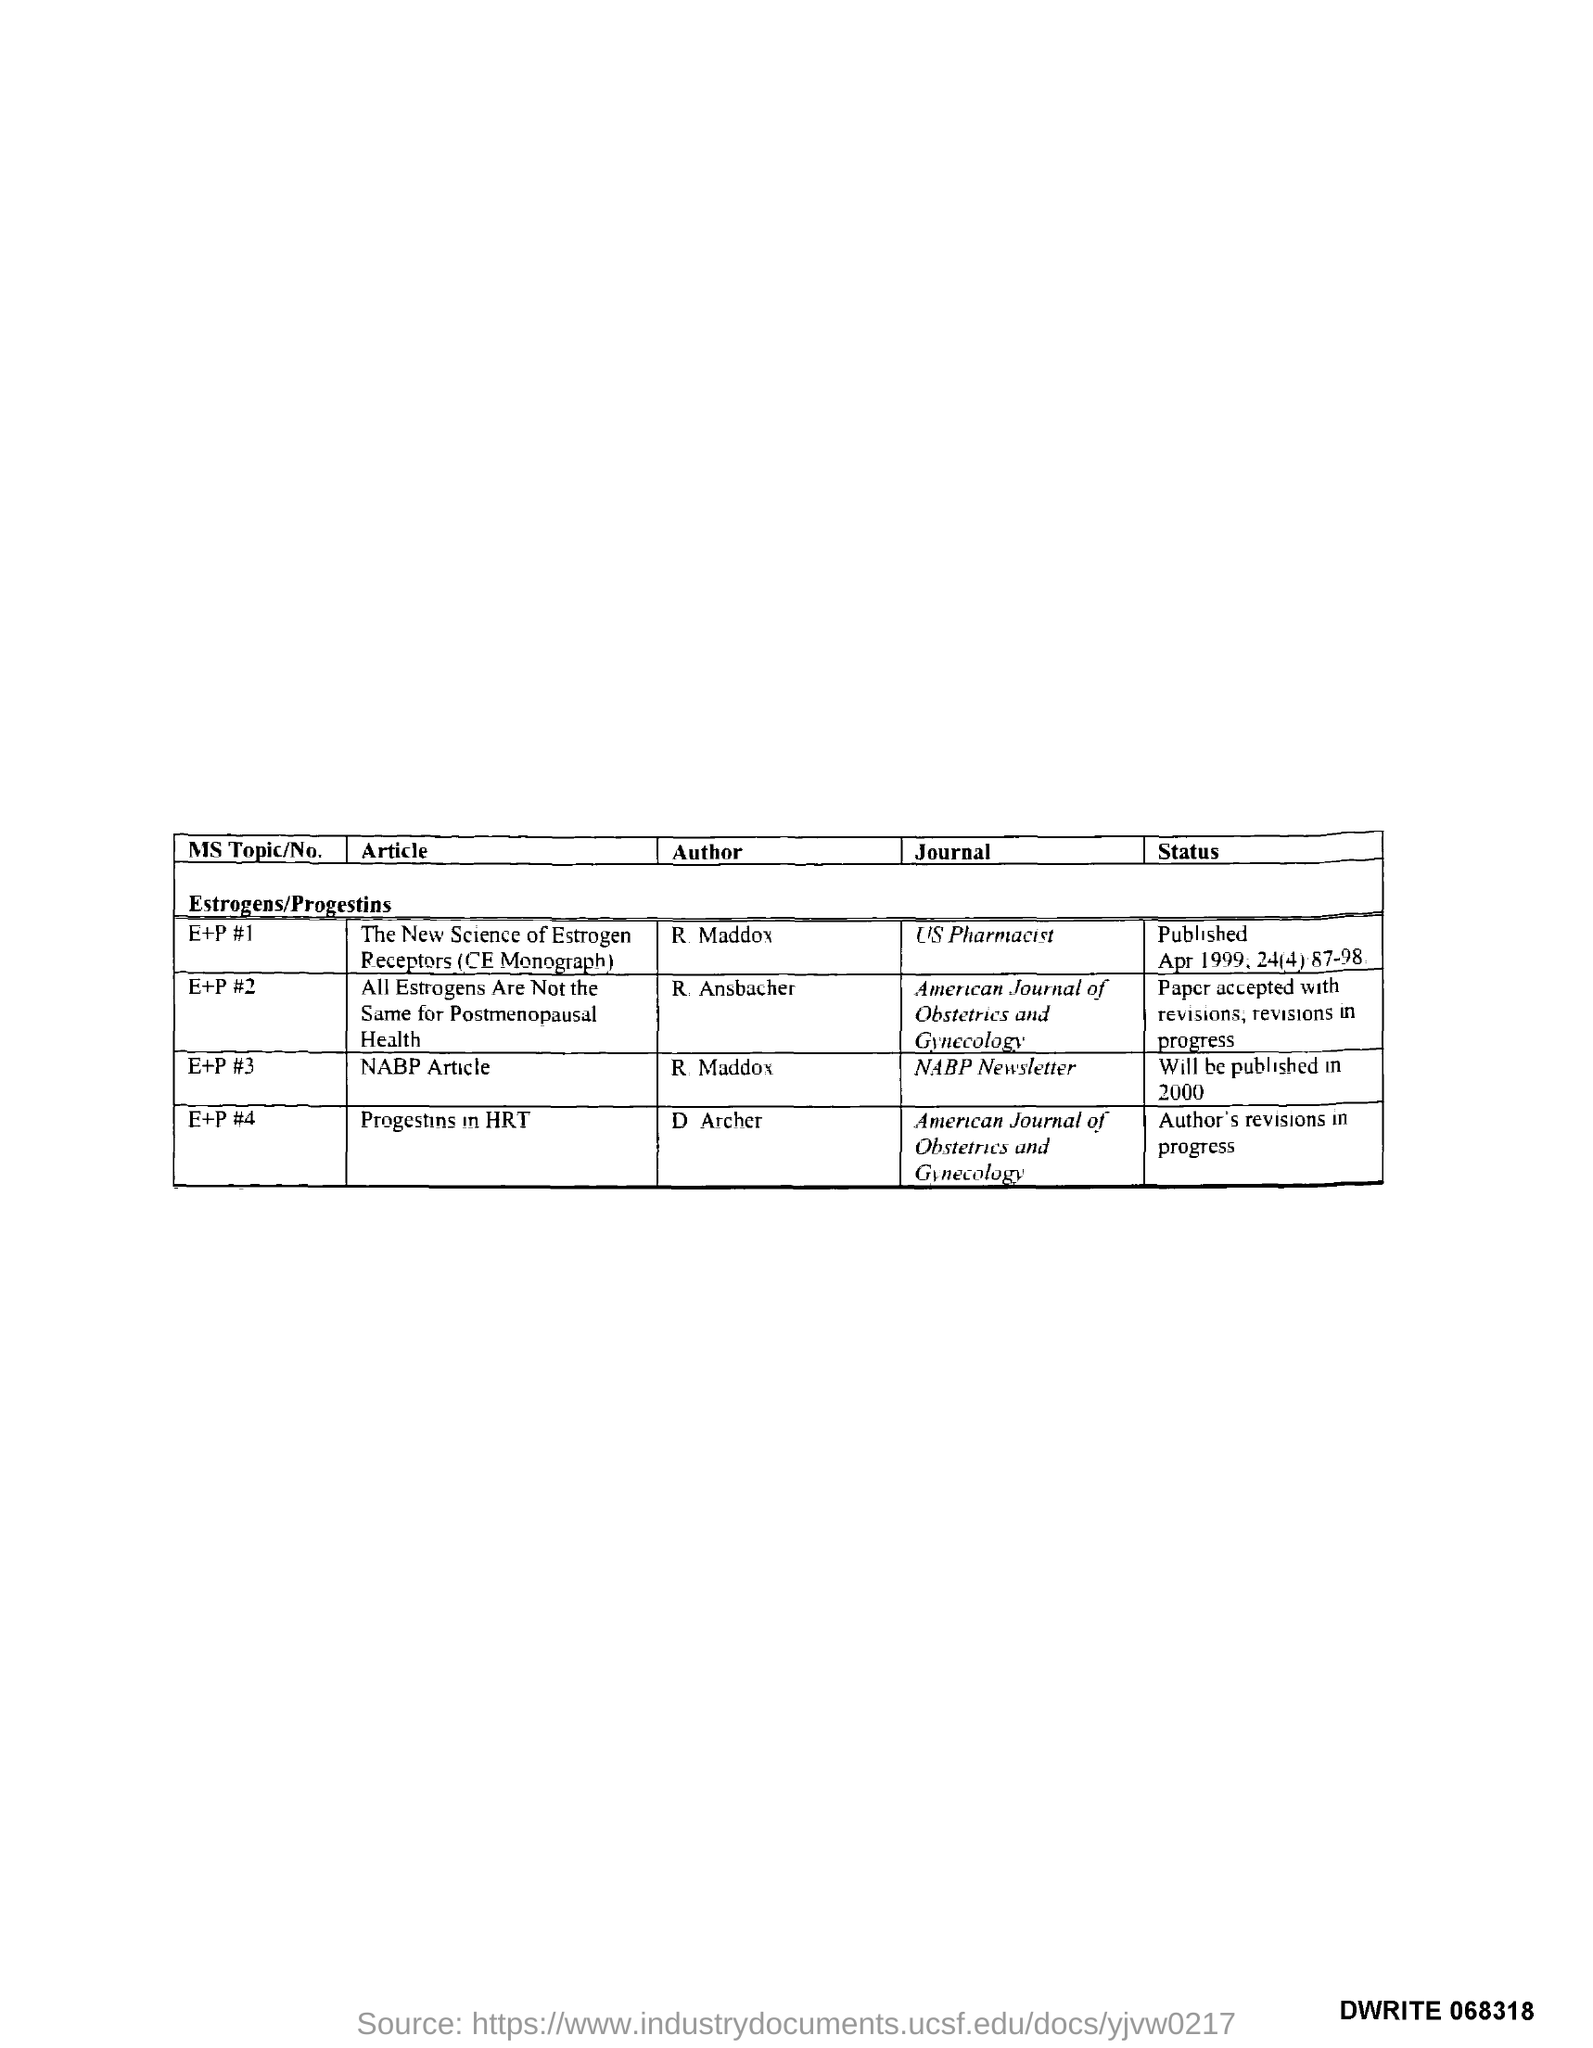Who is the author of the article titled "The New Science of Estrogen Receptors (CE Monograph)"?
Your response must be concise. R Maddox. In which journal , the article titled "The New Science of Estrogen Receptors (CE Monograph)" is published?
Provide a short and direct response. US Pharmacist. Who is the author of NABP Article?
Your response must be concise. R Maddox. Who is the author of the article titled "Progestins in HRT"?
Your answer should be very brief. D Archer. In which journal , the article titled "Progestins in HRT" is published?
Offer a very short reply. American Journal of Obstetrics and Gynecology. What is the status of the Article titled" Progestins in HRT"?
Your answer should be compact. Author's revisions in progress. 